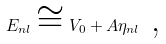Convert formula to latex. <formula><loc_0><loc_0><loc_500><loc_500>E _ { n l } \cong V _ { 0 } + A \eta _ { n l } \text { ,}</formula> 